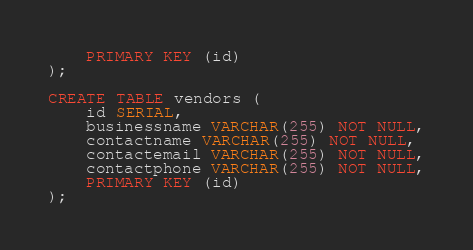Convert code to text. <code><loc_0><loc_0><loc_500><loc_500><_SQL_>	PRIMARY KEY (id)
);

CREATE TABLE vendors (
	id SERIAL,
	businessname VARCHAR(255) NOT NULL,
	contactname VARCHAR(255) NOT NULL,
	contactemail VARCHAR(255) NOT NULL,
	contactphone VARCHAR(255) NOT NULL,
	PRIMARY KEY (id)
);
</code> 